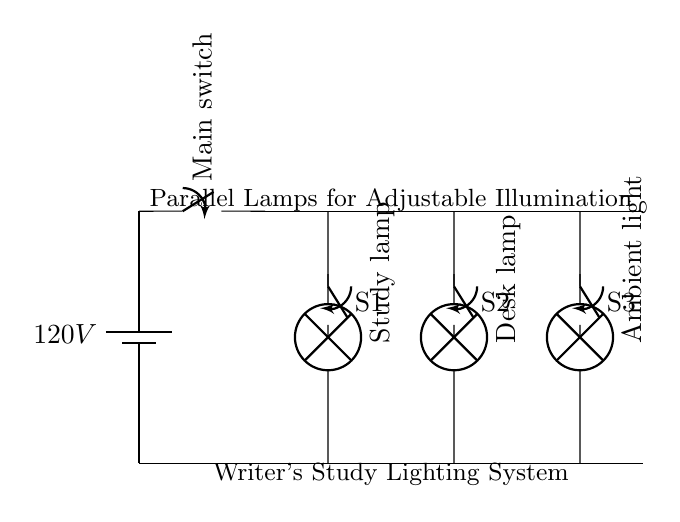What is the voltage of the power source? The circuit shows a battery labeled with a voltage of 120V, indicating the potential difference it provides to the entire circuit.
Answer: 120V How many lamps are in the circuit? The circuit diagram displays three lamps connected in parallel. Each lamp is individually represented, confirming their presence and helping identify how many are included in the lighting system.
Answer: Three What are the types of lamps used? The circuit specifies three different lamps: Study lamp, Desk lamp, and Ambient light, which can be identified by the labels next to each lamp icon in the diagram.
Answer: Study lamp, Desk lamp, Ambient light What type of circuit is this? The circuit is designed with lamps connected in parallel to a main power source, as indicated by the configuration that allows each lamp to operate independently from the others.
Answer: Parallel What happens if one lamp fails? Since the lamps are connected in parallel, if one lamp fails, the other lamps will continue to function because they each have their own path to the power source. This is a fundamental characteristic of parallel circuits that ensures uninterrupted service.
Answer: Others remain on How many switches are present in the circuit? There are three switches shown in the circuit for controlling each lamp independently, and this can be verified by counting the switch symbols next to each lamp connection.
Answer: Three 